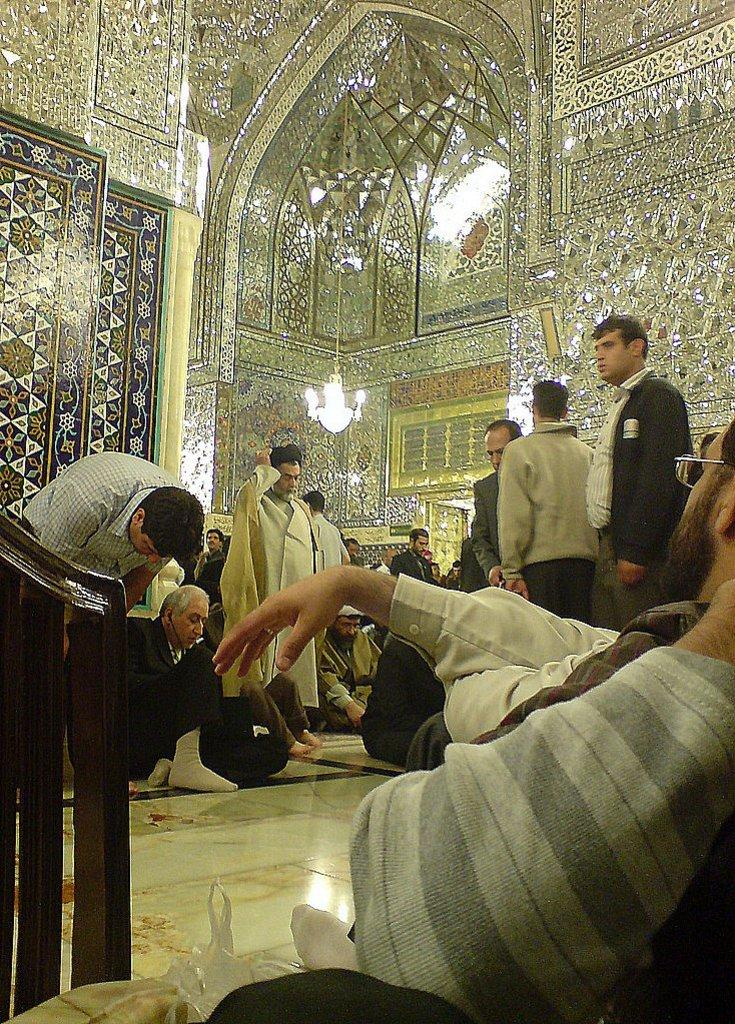What are the people in the image doing? There are people standing and sitting in the image. Where are the people located in the image? The people are on a path in the image. What is behind the people in the image? There is a wall behind the people in the image. Can you describe any other objects or features in the image? Yes, there is a chandelier in the image. What type of temper do the people in the image have? There is no information about the temper of the people in the image. Is there a volleyball game happening in the image? No, there is no volleyball game present in the image. 